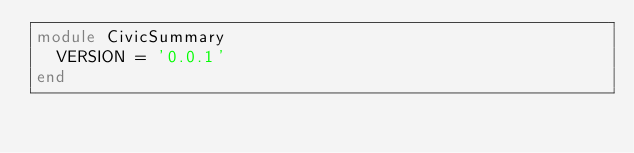Convert code to text. <code><loc_0><loc_0><loc_500><loc_500><_Ruby_>module CivicSummary
  VERSION = '0.0.1'
end
</code> 